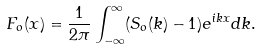Convert formula to latex. <formula><loc_0><loc_0><loc_500><loc_500>F _ { o } ( x ) = \frac { 1 } { 2 \pi } \int _ { - \infty } ^ { \infty } ( S _ { o } ( k ) - 1 ) e ^ { i k x } d k .</formula> 